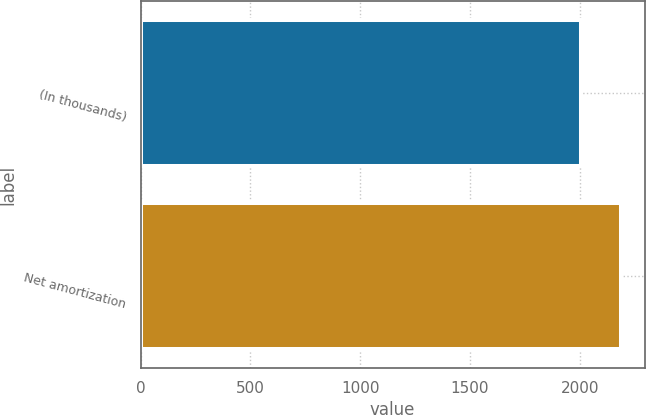Convert chart. <chart><loc_0><loc_0><loc_500><loc_500><bar_chart><fcel>(In thousands)<fcel>Net amortization<nl><fcel>2005<fcel>2186<nl></chart> 